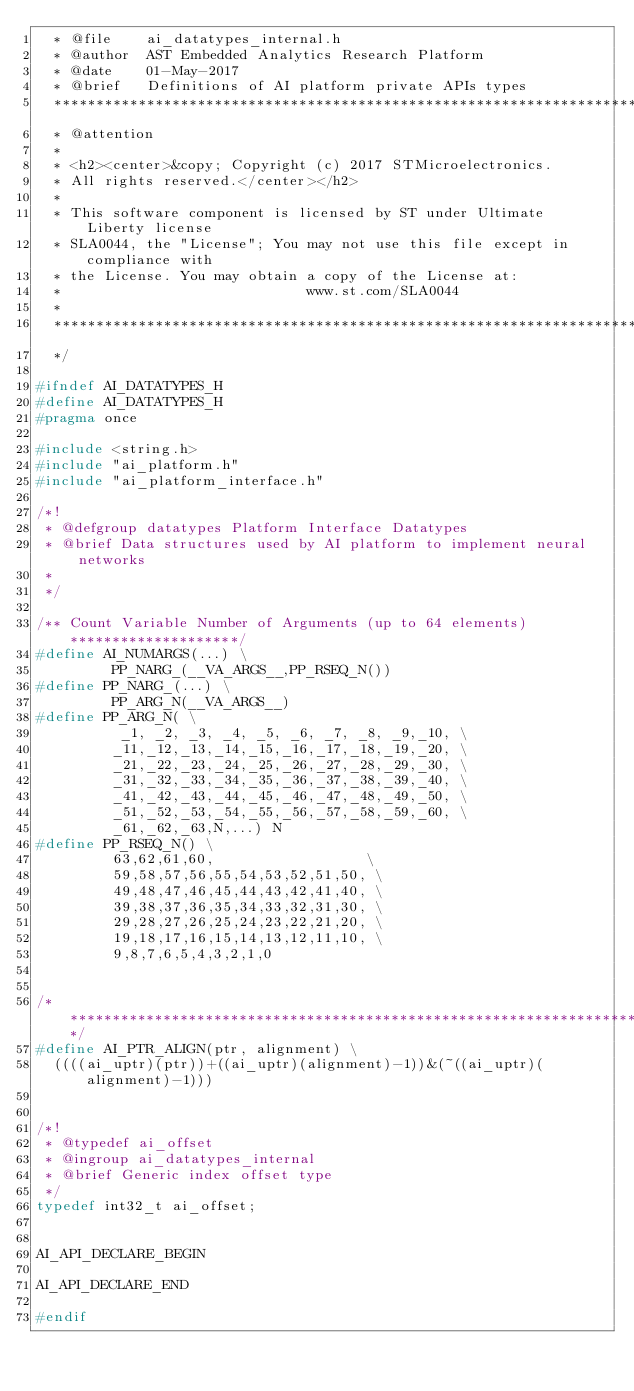<code> <loc_0><loc_0><loc_500><loc_500><_C_>  * @file    ai_datatypes_internal.h
  * @author  AST Embedded Analytics Research Platform
  * @date    01-May-2017
  * @brief   Definitions of AI platform private APIs types
  ******************************************************************************
  * @attention
  *
  * <h2><center>&copy; Copyright (c) 2017 STMicroelectronics.
  * All rights reserved.</center></h2>
  *
  * This software component is licensed by ST under Ultimate Liberty license
  * SLA0044, the "License"; You may not use this file except in compliance with
  * the License. You may obtain a copy of the License at:
  *                             www.st.com/SLA0044
  *
  ******************************************************************************
  */

#ifndef AI_DATATYPES_H
#define AI_DATATYPES_H
#pragma once

#include <string.h>
#include "ai_platform.h"
#include "ai_platform_interface.h"

/*!
 * @defgroup datatypes Platform Interface Datatypes
 * @brief Data structures used by AI platform to implement neural networks
 *
 */

/** Count Variable Number of Arguments (up to 64 elements) ********************/
#define AI_NUMARGS(...) \
         PP_NARG_(__VA_ARGS__,PP_RSEQ_N())
#define PP_NARG_(...) \
         PP_ARG_N(__VA_ARGS__)
#define PP_ARG_N( \
          _1, _2, _3, _4, _5, _6, _7, _8, _9,_10, \
         _11,_12,_13,_14,_15,_16,_17,_18,_19,_20, \
         _21,_22,_23,_24,_25,_26,_27,_28,_29,_30, \
         _31,_32,_33,_34,_35,_36,_37,_38,_39,_40, \
         _41,_42,_43,_44,_45,_46,_47,_48,_49,_50, \
         _51,_52,_53,_54,_55,_56,_57,_58,_59,_60, \
         _61,_62,_63,N,...) N
#define PP_RSEQ_N() \
         63,62,61,60,                  \
         59,58,57,56,55,54,53,52,51,50, \
         49,48,47,46,45,44,43,42,41,40, \
         39,38,37,36,35,34,33,32,31,30, \
         29,28,27,26,25,24,23,22,21,20, \
         19,18,17,16,15,14,13,12,11,10, \
         9,8,7,6,5,4,3,2,1,0


/******************************************************************************/
#define AI_PTR_ALIGN(ptr, alignment) \
  ((((ai_uptr)(ptr))+((ai_uptr)(alignment)-1))&(~((ai_uptr)(alignment)-1)))


/*!
 * @typedef ai_offset
 * @ingroup ai_datatypes_internal
 * @brief Generic index offset type
 */
typedef int32_t ai_offset;


AI_API_DECLARE_BEGIN

AI_API_DECLARE_END

#endif
</code> 